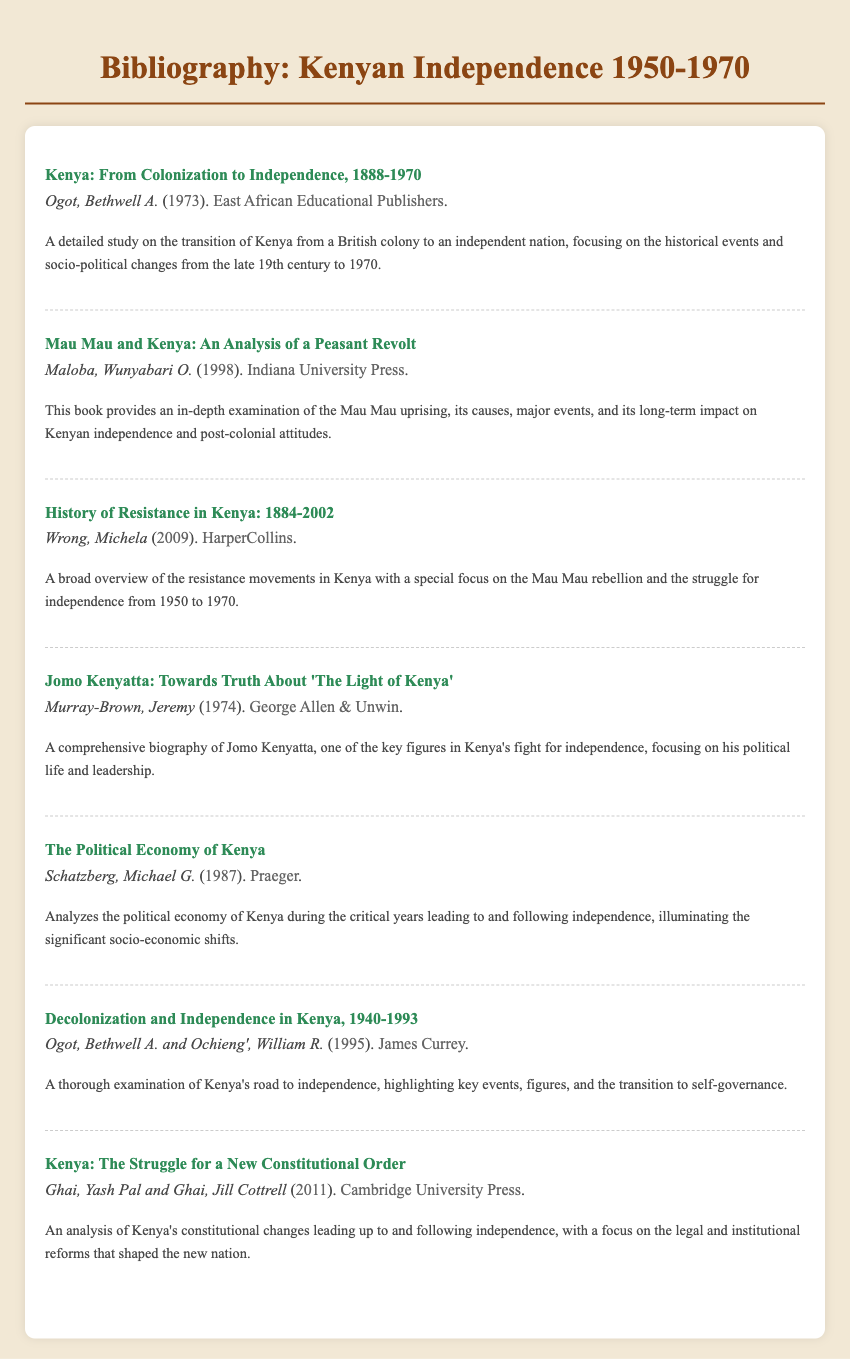What is the title of the first entry? The title of the first entry is presented at the top of the entry, which is "Kenya: From Colonization to Independence, 1888-1970."
Answer: Kenya: From Colonization to Independence, 1888-1970 Who is the author of the book "Mau Mau and Kenya"? The author’s name is included beneath the title in the entry for "Mau Mau and Kenya," which is Wunyabari O. Maloba.
Answer: Wunyabari O. Maloba What year was "History of Resistance in Kenya: 1884-2002" published? The publication year is clearly stated in the entry for the book, which is 2009.
Answer: 2009 Which publisher released "Jomo Kenyatta: Towards Truth About 'The Light of Kenya'"? The publisher's name is included in the entry for this book, which is George Allen & Unwin.
Answer: George Allen & Unwin How many authors contributed to "Decolonization and Independence in Kenya, 1940-1993"? The entry lists the authors' names, indicating that there are two contributors to this work, Bethwell A. Ogot and William R. Ochieng’.
Answer: Two What is the main focus of "The Political Economy of Kenya"? The description of the book indicates that it analyzes significant socio-economic shifts in Kenya during the years leading to and following independence.
Answer: Political economy What is the publication year of "Kenya: The Struggle for a New Constitutional Order"? The year is indicated in the entry for this book as 2011.
Answer: 2011 What does "Kenya: From Colonization to Independence, 1888-1970" address? The description stated focuses on the transition of Kenya from a British colony to an independent nation with a historical perspective.
Answer: Transition from colony to independence What type of document is this? This document is a bibliography, which consists of entries listing various sources related to Kenyan independence.
Answer: Bibliography 